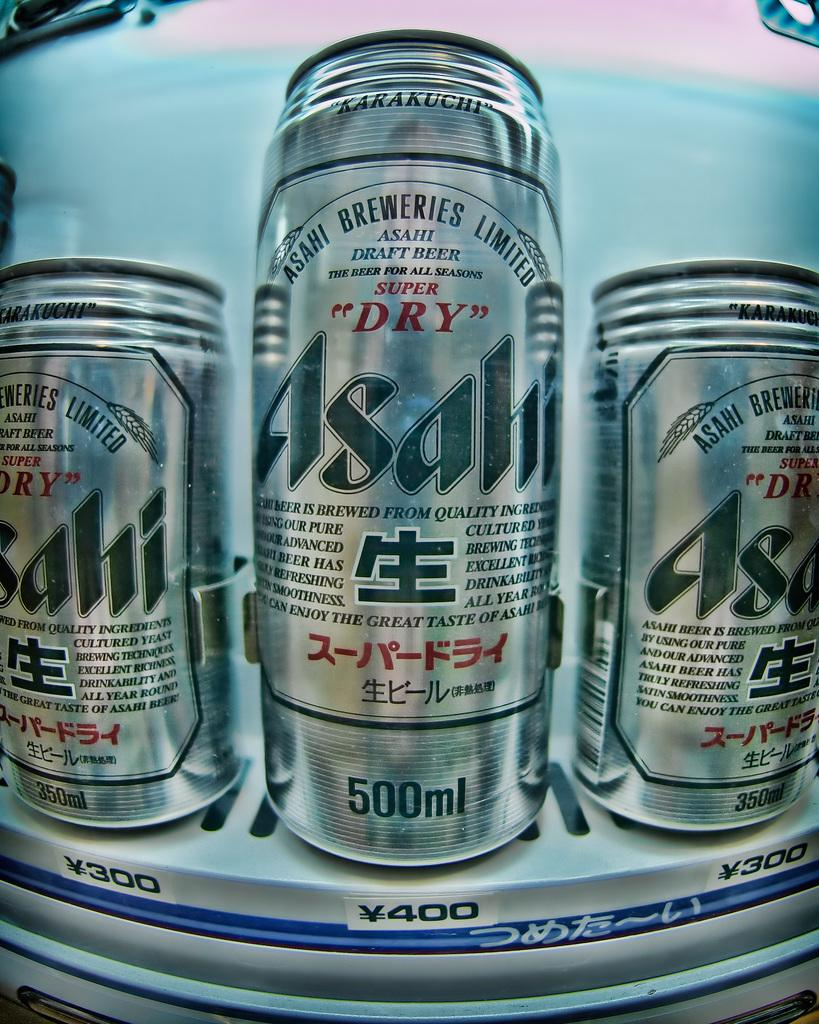<image>
Render a clear and concise summary of the photo. Several cans of Asahi are on display; one is 500 mL and the other two are 350 mL. 